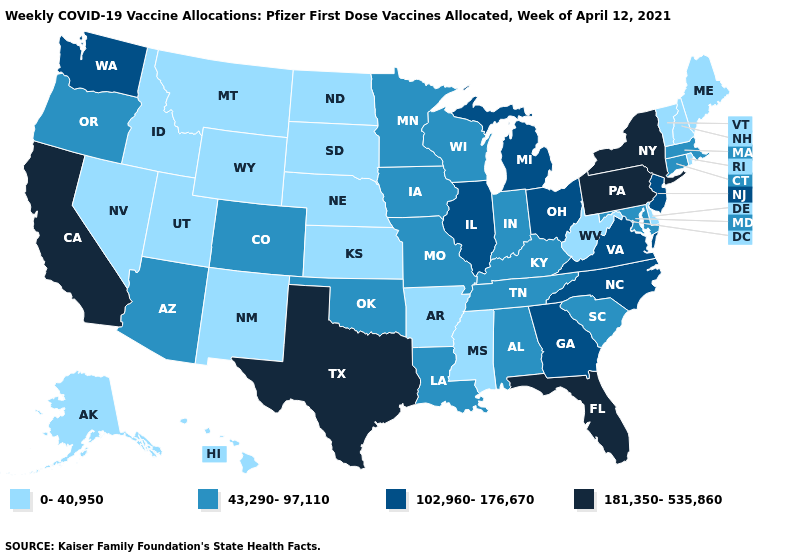What is the value of Oregon?
Be succinct. 43,290-97,110. Does the map have missing data?
Quick response, please. No. What is the highest value in states that border Georgia?
Be succinct. 181,350-535,860. What is the value of Florida?
Keep it brief. 181,350-535,860. Does the map have missing data?
Write a very short answer. No. What is the value of South Dakota?
Give a very brief answer. 0-40,950. Name the states that have a value in the range 181,350-535,860?
Keep it brief. California, Florida, New York, Pennsylvania, Texas. Which states have the lowest value in the USA?
Be succinct. Alaska, Arkansas, Delaware, Hawaii, Idaho, Kansas, Maine, Mississippi, Montana, Nebraska, Nevada, New Hampshire, New Mexico, North Dakota, Rhode Island, South Dakota, Utah, Vermont, West Virginia, Wyoming. Does Iowa have the lowest value in the USA?
Short answer required. No. What is the lowest value in the Northeast?
Be succinct. 0-40,950. Is the legend a continuous bar?
Keep it brief. No. Which states have the lowest value in the USA?
Quick response, please. Alaska, Arkansas, Delaware, Hawaii, Idaho, Kansas, Maine, Mississippi, Montana, Nebraska, Nevada, New Hampshire, New Mexico, North Dakota, Rhode Island, South Dakota, Utah, Vermont, West Virginia, Wyoming. Among the states that border Idaho , does Oregon have the lowest value?
Answer briefly. No. Does Georgia have the highest value in the South?
Short answer required. No. Which states have the lowest value in the USA?
Quick response, please. Alaska, Arkansas, Delaware, Hawaii, Idaho, Kansas, Maine, Mississippi, Montana, Nebraska, Nevada, New Hampshire, New Mexico, North Dakota, Rhode Island, South Dakota, Utah, Vermont, West Virginia, Wyoming. 